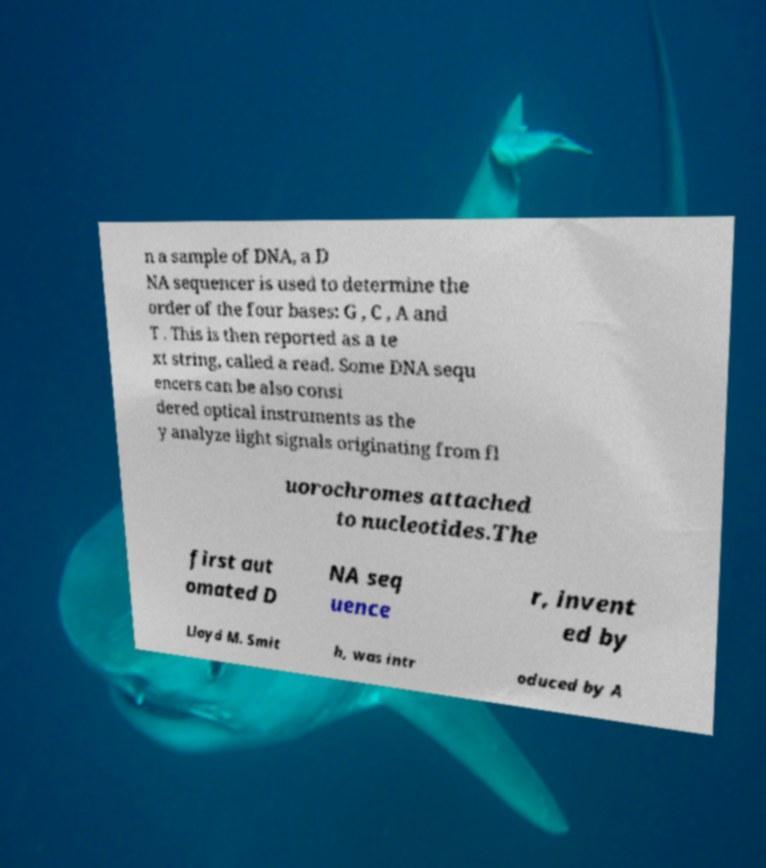Could you assist in decoding the text presented in this image and type it out clearly? n a sample of DNA, a D NA sequencer is used to determine the order of the four bases: G , C , A and T . This is then reported as a te xt string, called a read. Some DNA sequ encers can be also consi dered optical instruments as the y analyze light signals originating from fl uorochromes attached to nucleotides.The first aut omated D NA seq uence r, invent ed by Lloyd M. Smit h, was intr oduced by A 